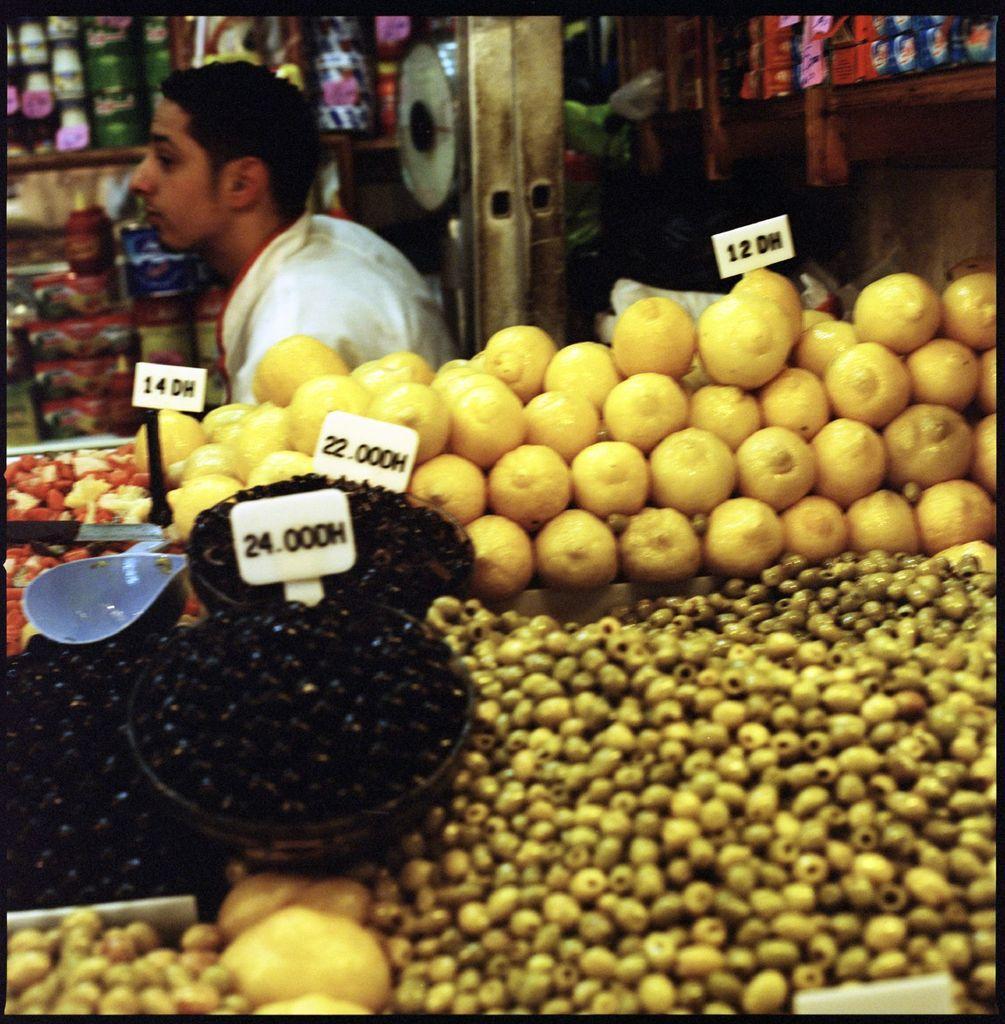In one or two sentences, can you explain what this image depicts? In this image I can see different types of food and I can also see few white colour price tags. In the background I can see a man and I can see he is wearing white dress. I can also see few other stuffs in background. 